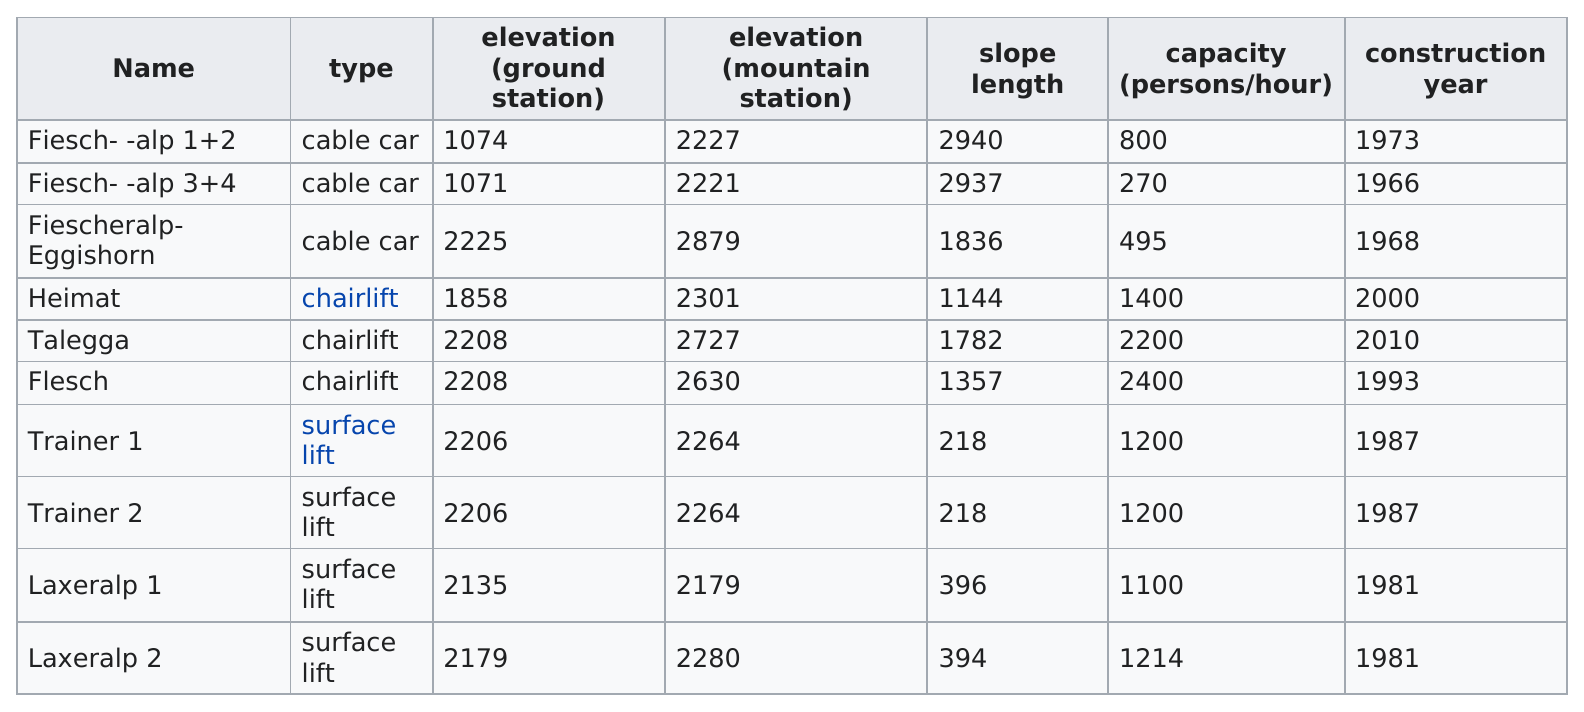Give some essential details in this illustration. The number of capacity for LAXALP 2 is 1214. The Fiesch-Rote-Alp cable car is the oldest. The name Talegga was used in the last construction year. The name of the person who was trained by Trainer 1 is unknown. Trainer 2 then trained that person. The trainer 1 is a surface lift, not a cable car. 